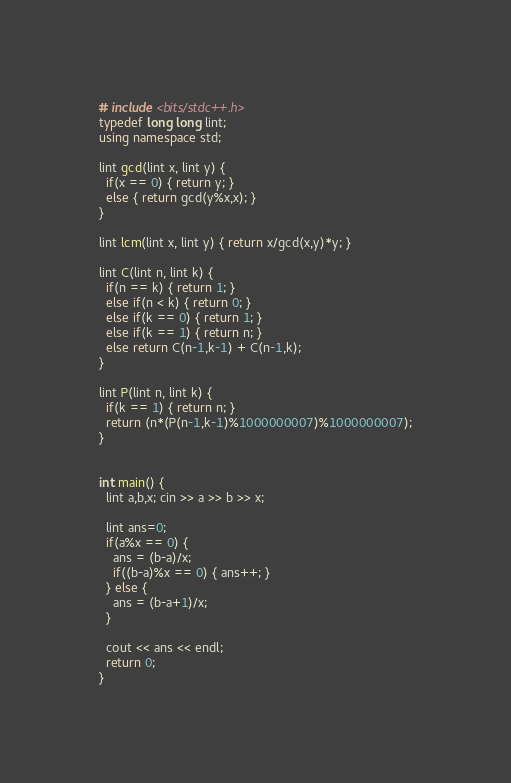Convert code to text. <code><loc_0><loc_0><loc_500><loc_500><_C++_># include <bits/stdc++.h>
typedef long long lint;
using namespace std;

lint gcd(lint x, lint y) {
  if(x == 0) { return y; }
  else { return gcd(y%x,x); }
}

lint lcm(lint x, lint y) { return x/gcd(x,y)*y; }

lint C(lint n, lint k) {
  if(n == k) { return 1; }
  else if(n < k) { return 0; }
  else if(k == 0) { return 1; }
  else if(k == 1) { return n; }
  else return C(n-1,k-1) + C(n-1,k);
}

lint P(lint n, lint k) {
  if(k == 1) { return n; }
  return (n*(P(n-1,k-1)%1000000007)%1000000007);
}


int main() {
  lint a,b,x; cin >> a >> b >> x;

  lint ans=0;
  if(a%x == 0) {
    ans = (b-a)/x;
    if((b-a)%x == 0) { ans++; }
  } else {
    ans = (b-a+1)/x;
  }

  cout << ans << endl;
  return 0;
}
</code> 